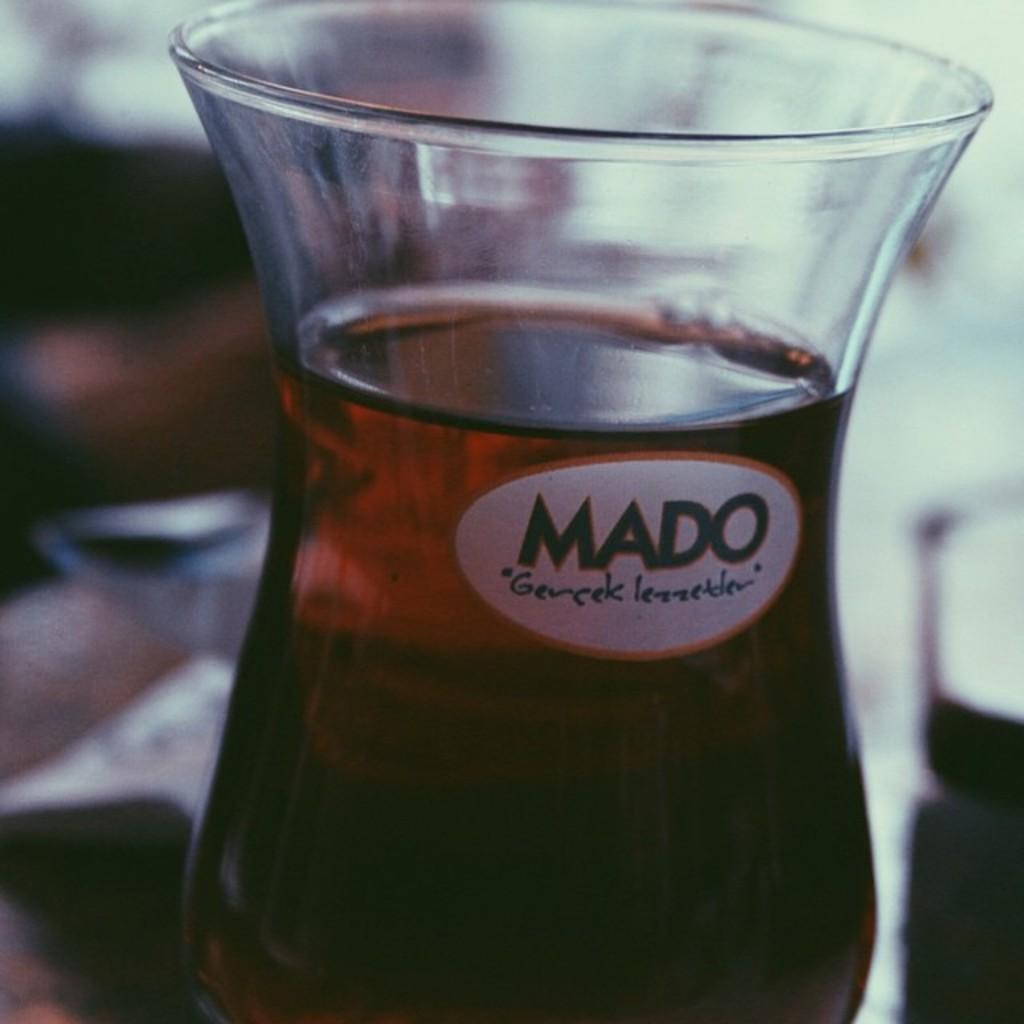What is the brand name on this bottle?
Make the answer very short. Mado. 